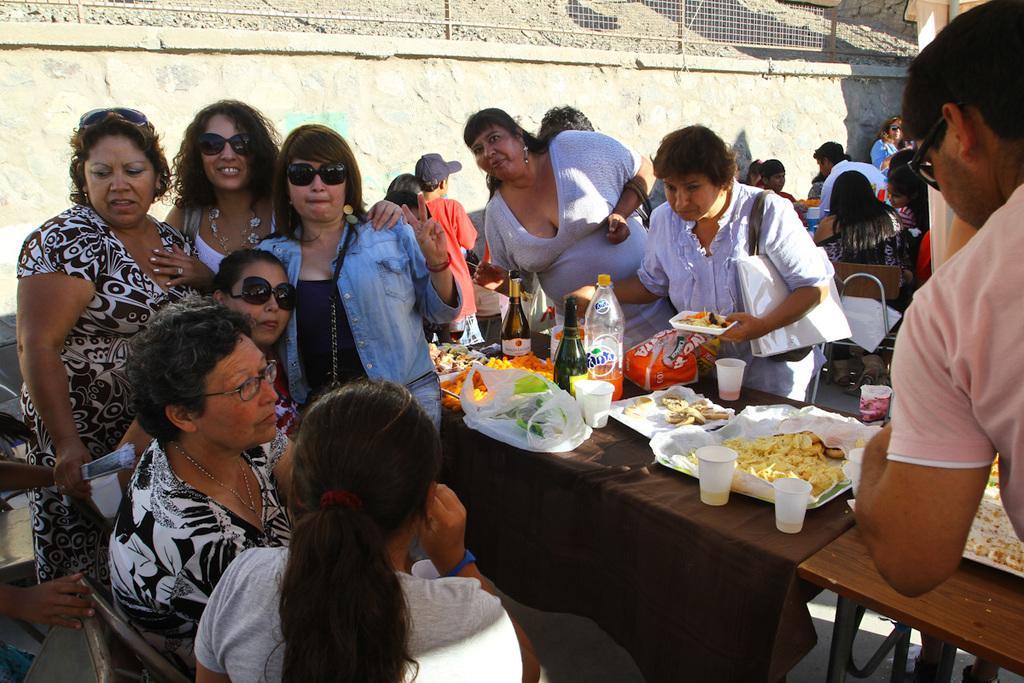Can you describe this image briefly? In this picture few persons sitting on the chair. There are few persons standing. There is a table. On the table we can see bottle cup,food,cover. In this background we can see wall and fence. 